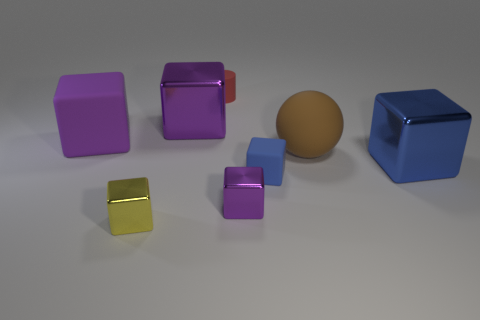How many purple cubes must be subtracted to get 1 purple cubes? 2 Subtract all small purple cubes. How many cubes are left? 5 Add 1 large purple metallic cubes. How many objects exist? 9 Subtract all purple blocks. How many blocks are left? 3 Subtract 1 cylinders. How many cylinders are left? 0 Add 2 brown spheres. How many brown spheres exist? 3 Subtract 1 brown spheres. How many objects are left? 7 Subtract all cubes. How many objects are left? 2 Subtract all purple spheres. Subtract all gray blocks. How many spheres are left? 1 Subtract all green cylinders. How many yellow cubes are left? 1 